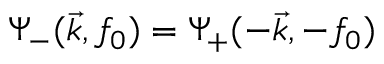<formula> <loc_0><loc_0><loc_500><loc_500>\Psi _ { - } ( \vec { k } , f _ { 0 } ) = \Psi _ { + } ( - \vec { k } , - f _ { 0 } )</formula> 